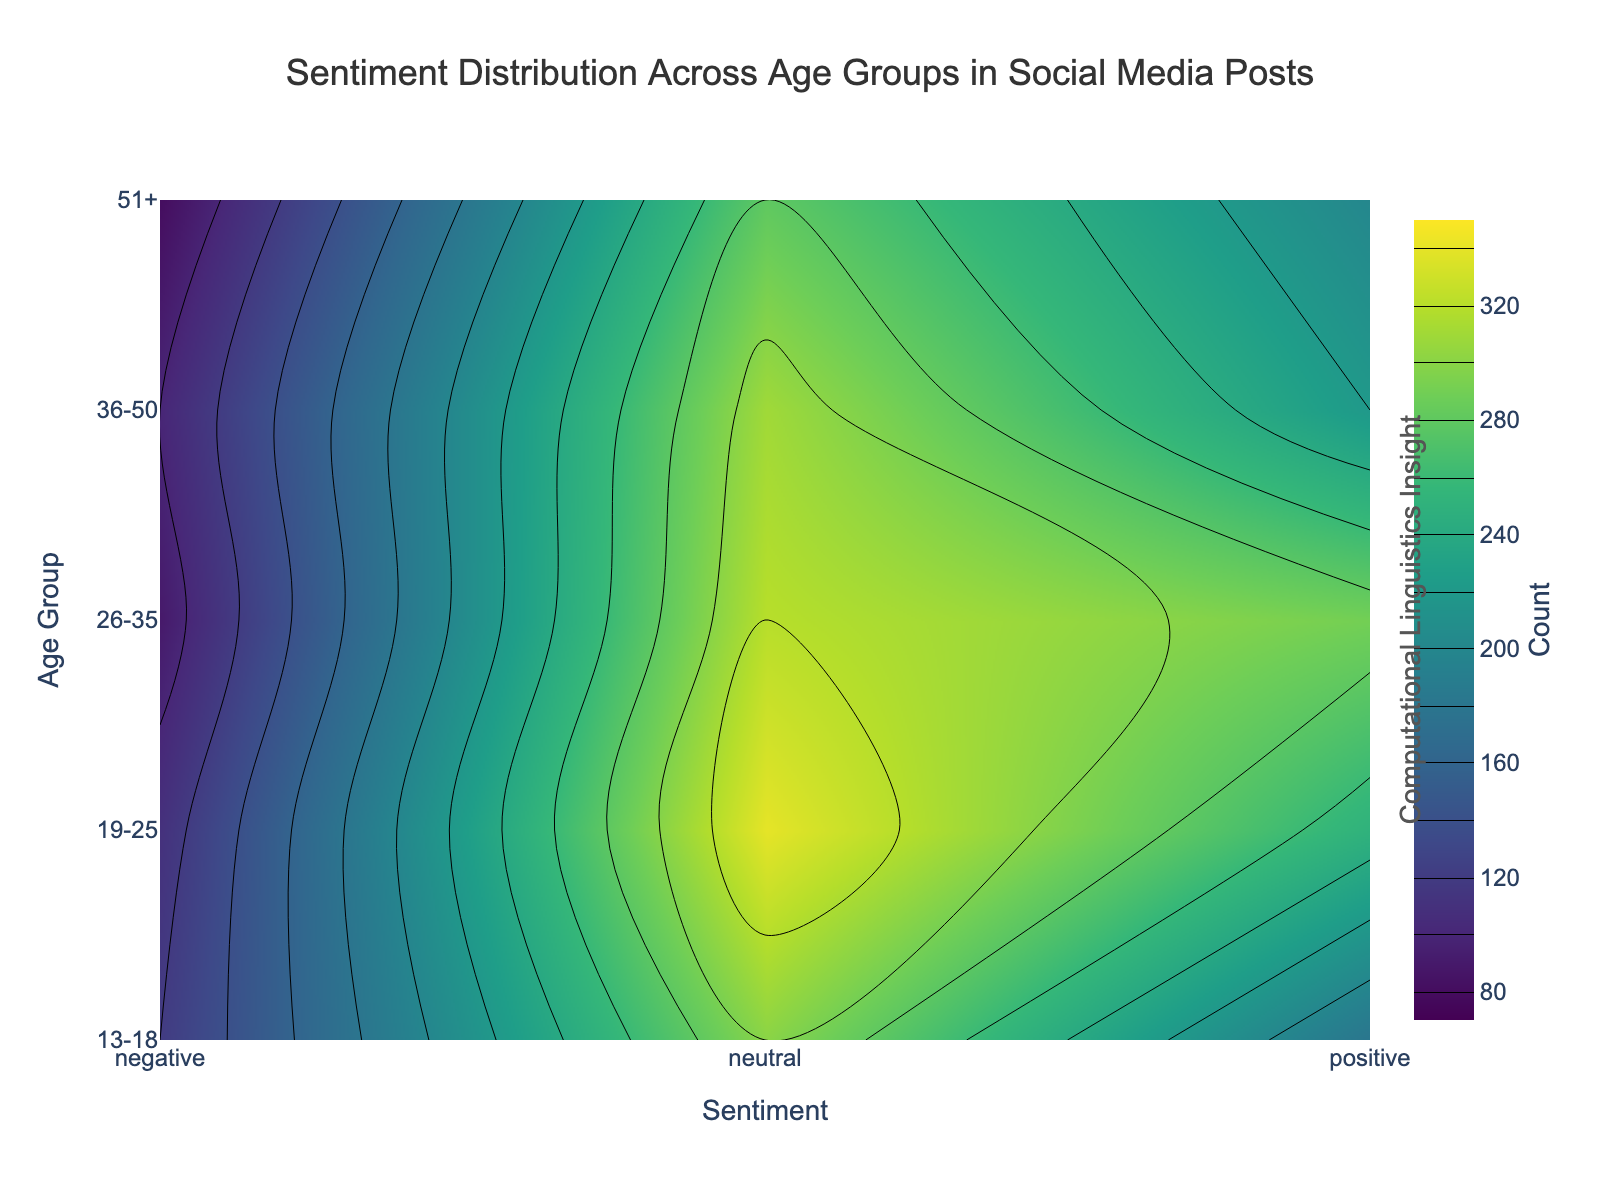What is the overall title of the plot? The title is typically displayed prominently at the top of the plot, indicating what the visualization represents. Here, it reads "Sentiment Distribution Across Age Groups in Social Media Posts."
Answer: Sentiment Distribution Across Age Groups in Social Media Posts Which age group shows the highest count of positive sentiment posts? Look at the y-axis for age groups and the corresponding color intensities for positive sentiment (x-axis label 'Positive'). In the '26-35' age group, the color for positive sentiment is the most intensive.
Answer: 26-35 What is the range set for the contour levels in the plot? The contour levels are displayed through color gradients between the minimum and maximum counts indicated on the color bar. The range is specified in the contours section of the code as starting at 80 and ending at 340.
Answer: 80 to 340 Which age group exhibits the smallest total count of sentiment posts? Sum the counts of all sentiments for each age group. The '51+' age group has (80 + 280 + 200) = 560, which is the smallest total.
Answer: 51+ How does the distribution of neutral sentiment compare between the age groups? Neutral sentiment counts are along the 'neutral' x-axis. The color intensity indicates that '19-25' has the highest count, as shown by the darkest color, followed by '26-35', '36-50', '13-18', and '51+.'
Answer: 19-25 has the highest, followed by 26-35, 36-50, 13-18, and 51+ Are there any age groups that exhibit similar patterns in sentiment distribution? Compare the color gradients across different age groups. The '13-18' and '36-50' age groups show similar patterns where neutral sentiment is highest, followed by positive and then negative.
Answer: 13-18 and 36-50 Which sentiment type has the highest overall count across all age groups? Summing the counts for each sentiment type across age groups, neutral stands out with values (300 + 340 + 320 + 310 + 280 = 1550), which is highest.
Answer: Neutral What is the average count of negative sentiment posts across all age groups? Sum the counts for negative sentiment (120 + 110 + 90 + 100 + 80) and divide by the number of age groups, which is 5. (120 + 110 + 90 + 100 + 80) / 5 = 100.
Answer: 100 How does the sentiment distribution for the '36-50' age group compare to '19-25'? Compare the counts of each sentiment for '36-50' and '19-25': 
Negative: 100 (36-50) vs. 110 (19-25),
Neutral: 310 (36-50) vs. 340 (19-25), 
Positive: 220 (36-50) vs. 250 (19-25).
'19-25' consistently has slightly higher counts for each sentiment type.
Answer: '19-25' has slightly higher counts across all sentiments 